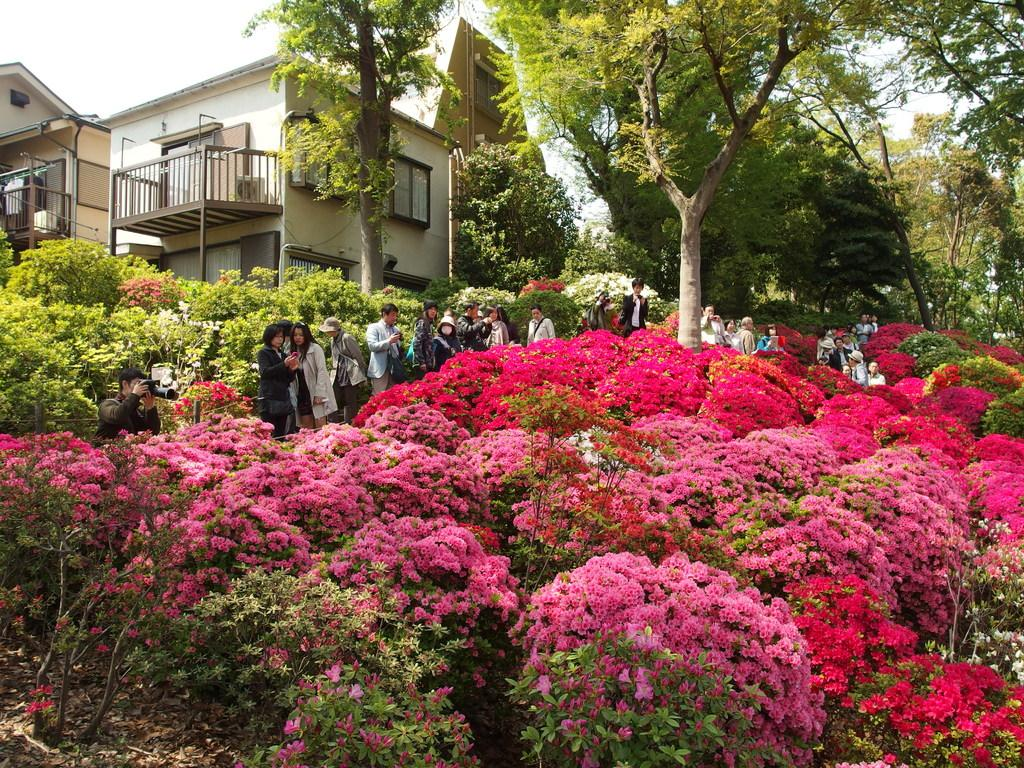What type of plants can be seen in the image? There are flower plants in the image. What is located behind the flower plants? There are people standing behind the flower plants. What can be seen in the distance in the image? There are trees and houses in the background of the image. Is there a birthday celebration happening near the lake in the image? There is no lake or birthday celebration present in the image. 